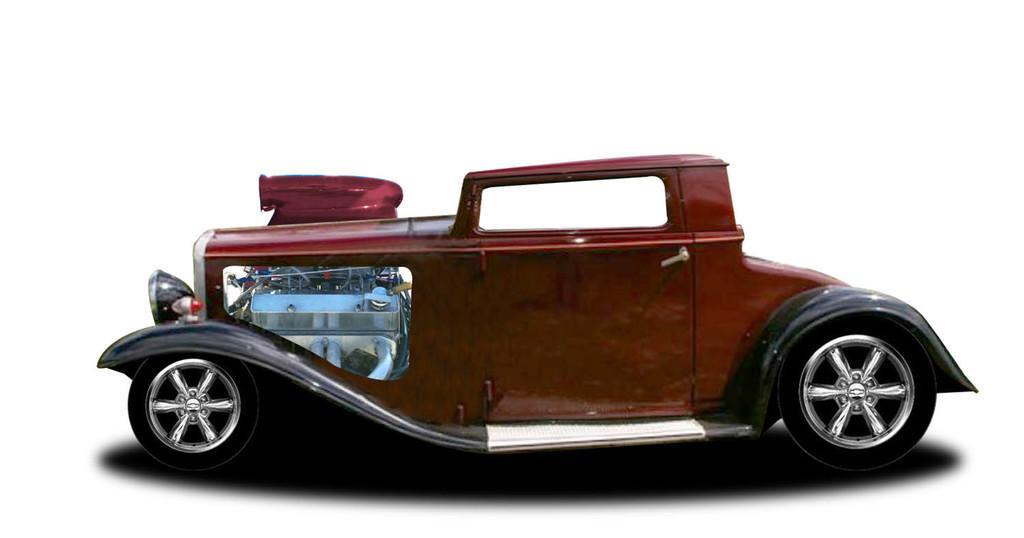In one or two sentences, can you explain what this image depicts? In this picture I can see there is a car and in the backdrop there is a white surface. 